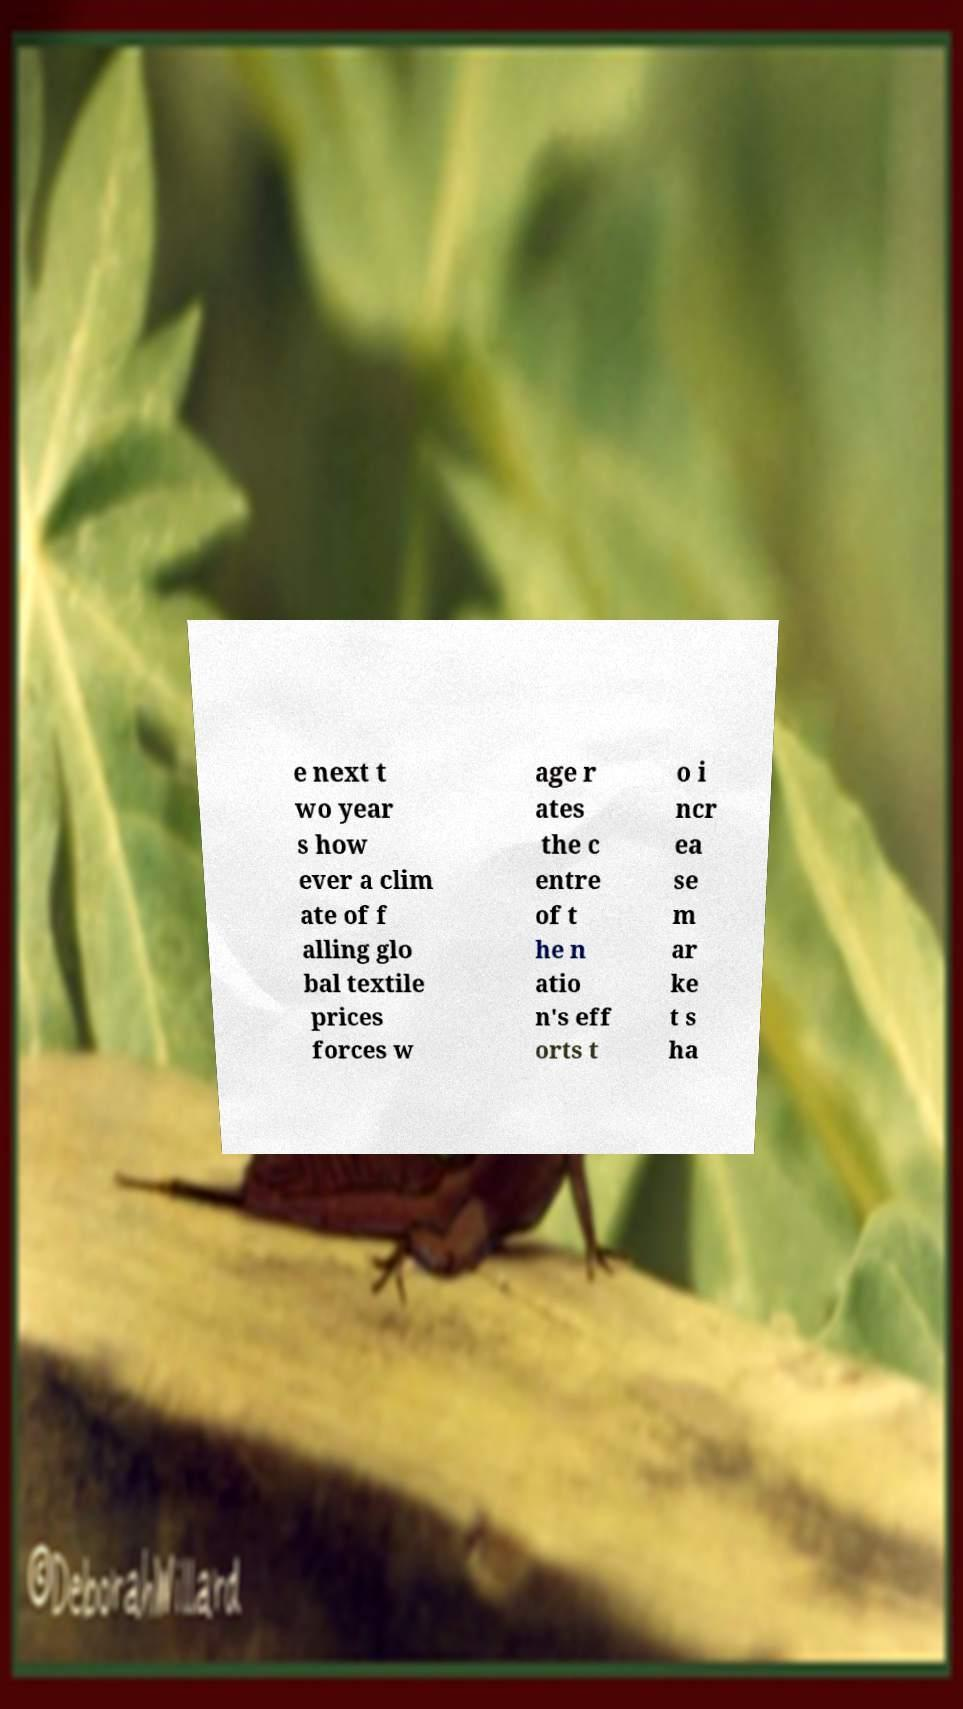Please read and relay the text visible in this image. What does it say? e next t wo year s how ever a clim ate of f alling glo bal textile prices forces w age r ates the c entre of t he n atio n's eff orts t o i ncr ea se m ar ke t s ha 